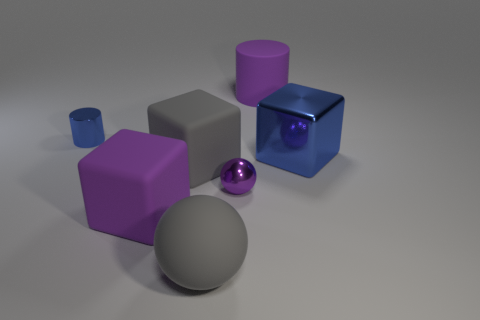What number of objects are purple rubber things in front of the gray cube or purple rubber blocks?
Your answer should be very brief. 1. What is the size of the gray object in front of the metal ball?
Keep it short and to the point. Large. What material is the large purple cylinder?
Your answer should be compact. Rubber. The tiny shiny thing to the left of the shiny object that is in front of the large gray matte cube is what shape?
Offer a very short reply. Cylinder. How many other things are the same shape as the small purple object?
Provide a succinct answer. 1. There is a blue metallic cylinder; are there any big things behind it?
Your answer should be very brief. Yes. The rubber ball is what color?
Ensure brevity in your answer.  Gray. There is a large metallic cube; is its color the same as the cylinder that is on the left side of the matte cylinder?
Provide a succinct answer. Yes. Are there any gray rubber spheres that have the same size as the rubber cylinder?
Keep it short and to the point. Yes. What size is the object that is the same color as the big metallic block?
Make the answer very short. Small. 